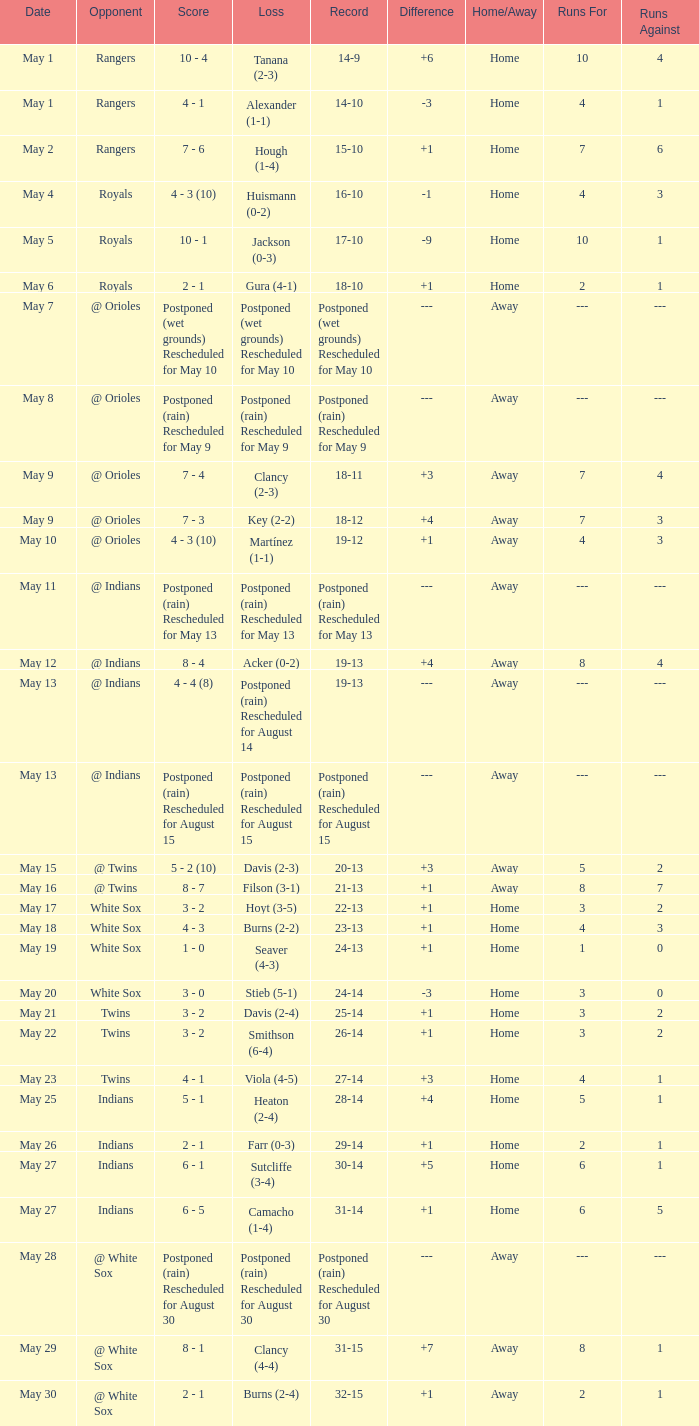What was date of the game when the record was 31-15? May 29. 